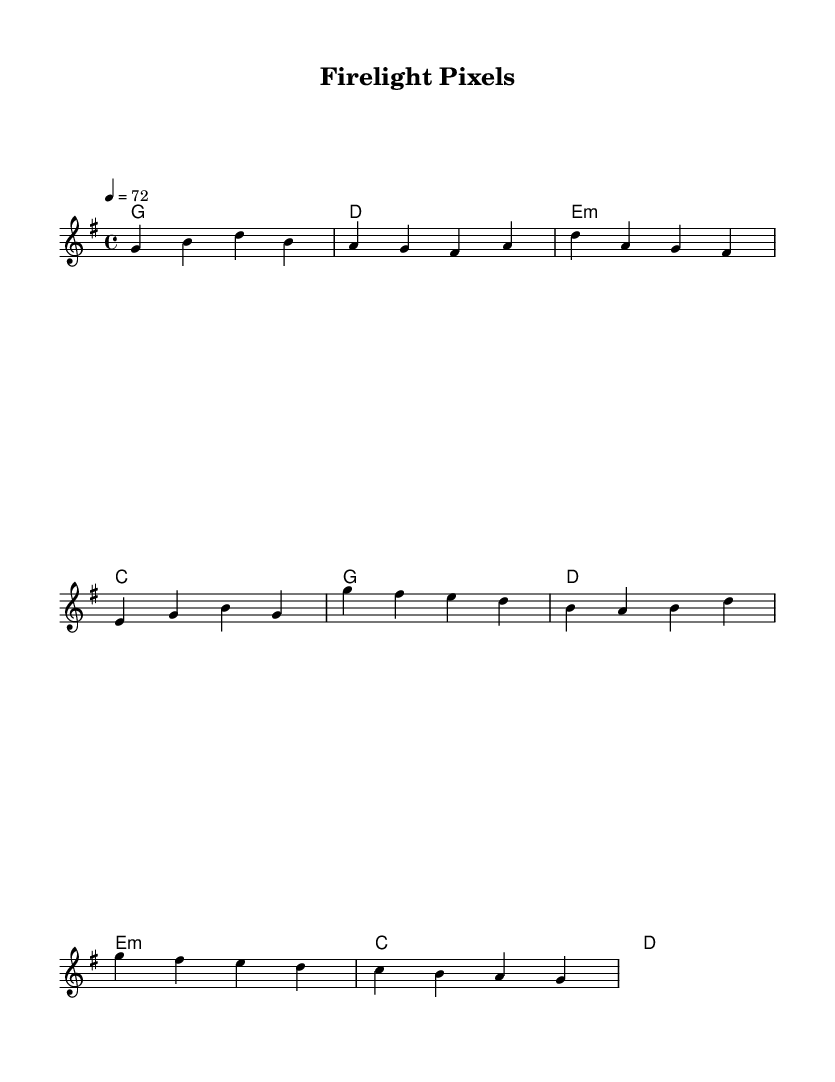What is the key signature of this music? The key signature is G major, which has one sharp (F#).
Answer: G major What is the time signature of this piece? The time signature is four-four, indicating four beats per measure.
Answer: 4/4 What is the tempo marking in the score? The score has a tempo marking of 72 beats per minute, noted at the beginning.
Answer: 72 How many measures are in the verse section? The verse section is made up of four measures as indicated by the bar lines.
Answer: 4 What is the first chord of the harmony? The first chord of the harmony is G major, seen in the first measure.
Answer: G major Which part has the higher pitch, the melody or harmonies? The melody part is higher in pitch compared to the harmonies, containing notes that typically extend above the harmonies.
Answer: Melody What style does this music represent, combining elements of which genres? This music represents a fusion of folk and electronic styles, as suggested by its structure and instrumentation suitable for cozy settings.
Answer: Folk-electronic fusion 